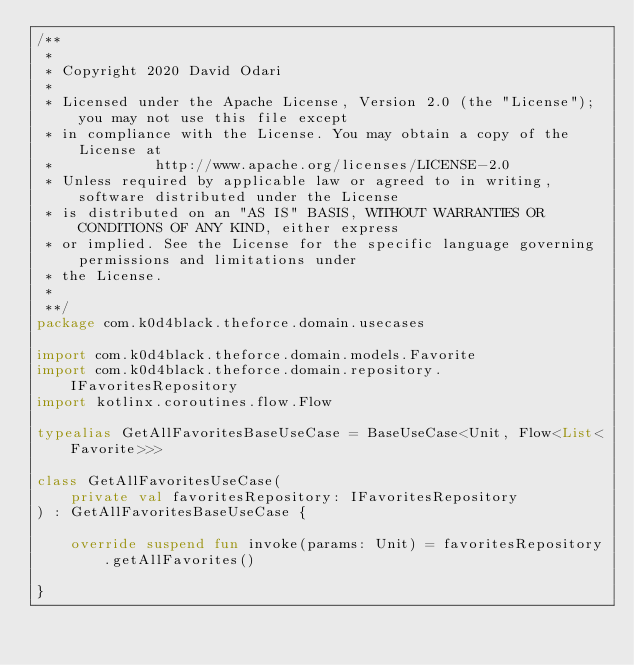<code> <loc_0><loc_0><loc_500><loc_500><_Kotlin_>/**
 *
 * Copyright 2020 David Odari
 *
 * Licensed under the Apache License, Version 2.0 (the "License"); you may not use this file except
 * in compliance with the License. You may obtain a copy of the License at
 *            http://www.apache.org/licenses/LICENSE-2.0
 * Unless required by applicable law or agreed to in writing, software distributed under the License
 * is distributed on an "AS IS" BASIS, WITHOUT WARRANTIES OR CONDITIONS OF ANY KIND, either express
 * or implied. See the License for the specific language governing permissions and limitations under
 * the License.
 *
 **/
package com.k0d4black.theforce.domain.usecases

import com.k0d4black.theforce.domain.models.Favorite
import com.k0d4black.theforce.domain.repository.IFavoritesRepository
import kotlinx.coroutines.flow.Flow

typealias GetAllFavoritesBaseUseCase = BaseUseCase<Unit, Flow<List<Favorite>>>

class GetAllFavoritesUseCase(
    private val favoritesRepository: IFavoritesRepository
) : GetAllFavoritesBaseUseCase {

    override suspend fun invoke(params: Unit) = favoritesRepository.getAllFavorites()

}</code> 